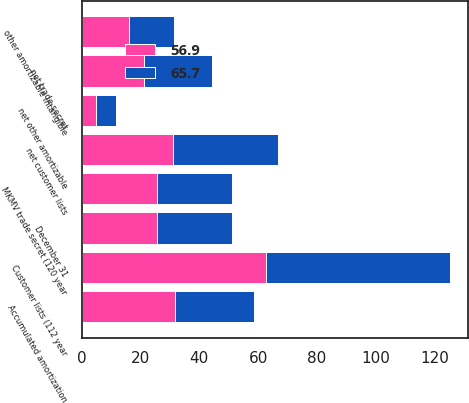Convert chart to OTSL. <chart><loc_0><loc_0><loc_500><loc_500><stacked_bar_chart><ecel><fcel>December 31<fcel>Customer lists (112 year<fcel>Accumulated amortization<fcel>net customer lists<fcel>MKMV trade secret (120 year<fcel>net trade secret<fcel>other amortizable intangible<fcel>net other amortizable<nl><fcel>56.9<fcel>25.5<fcel>62.7<fcel>31.8<fcel>30.9<fcel>25.5<fcel>21.1<fcel>16.1<fcel>4.9<nl><fcel>65.7<fcel>25.5<fcel>62.5<fcel>26.8<fcel>35.7<fcel>25.5<fcel>23.2<fcel>15.4<fcel>6.8<nl></chart> 